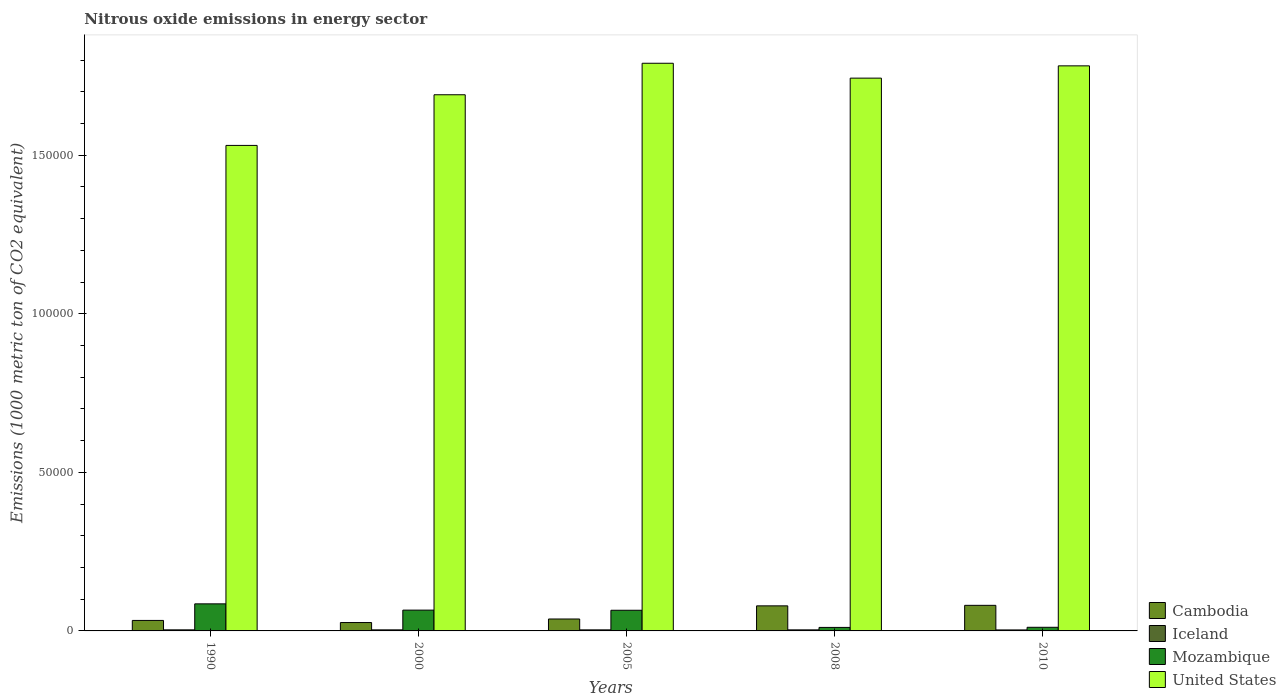In how many cases, is the number of bars for a given year not equal to the number of legend labels?
Offer a very short reply. 0. What is the amount of nitrous oxide emitted in Iceland in 2000?
Your answer should be compact. 331.8. Across all years, what is the maximum amount of nitrous oxide emitted in Mozambique?
Your answer should be compact. 8537. Across all years, what is the minimum amount of nitrous oxide emitted in United States?
Offer a very short reply. 1.53e+05. In which year was the amount of nitrous oxide emitted in Mozambique minimum?
Keep it short and to the point. 2008. What is the total amount of nitrous oxide emitted in Mozambique in the graph?
Provide a short and direct response. 2.39e+04. What is the difference between the amount of nitrous oxide emitted in Mozambique in 1990 and that in 2005?
Offer a terse response. 2022.8. What is the difference between the amount of nitrous oxide emitted in Iceland in 2000 and the amount of nitrous oxide emitted in United States in 1990?
Make the answer very short. -1.53e+05. What is the average amount of nitrous oxide emitted in Cambodia per year?
Keep it short and to the point. 5136.94. In the year 2000, what is the difference between the amount of nitrous oxide emitted in Cambodia and amount of nitrous oxide emitted in Mozambique?
Provide a succinct answer. -3912.3. What is the ratio of the amount of nitrous oxide emitted in Mozambique in 1990 to that in 2000?
Ensure brevity in your answer.  1.3. Is the amount of nitrous oxide emitted in United States in 2000 less than that in 2005?
Your response must be concise. Yes. Is the difference between the amount of nitrous oxide emitted in Cambodia in 1990 and 2008 greater than the difference between the amount of nitrous oxide emitted in Mozambique in 1990 and 2008?
Your answer should be compact. No. What is the difference between the highest and the second highest amount of nitrous oxide emitted in Mozambique?
Provide a short and direct response. 1979.8. What is the difference between the highest and the lowest amount of nitrous oxide emitted in Cambodia?
Offer a terse response. 5421.9. In how many years, is the amount of nitrous oxide emitted in United States greater than the average amount of nitrous oxide emitted in United States taken over all years?
Ensure brevity in your answer.  3. Is it the case that in every year, the sum of the amount of nitrous oxide emitted in Iceland and amount of nitrous oxide emitted in Mozambique is greater than the sum of amount of nitrous oxide emitted in United States and amount of nitrous oxide emitted in Cambodia?
Keep it short and to the point. No. What does the 3rd bar from the left in 1990 represents?
Ensure brevity in your answer.  Mozambique. Is it the case that in every year, the sum of the amount of nitrous oxide emitted in Cambodia and amount of nitrous oxide emitted in United States is greater than the amount of nitrous oxide emitted in Iceland?
Provide a succinct answer. Yes. Are all the bars in the graph horizontal?
Give a very brief answer. No. What is the difference between two consecutive major ticks on the Y-axis?
Provide a succinct answer. 5.00e+04. Does the graph contain any zero values?
Provide a short and direct response. No. Does the graph contain grids?
Offer a very short reply. No. What is the title of the graph?
Keep it short and to the point. Nitrous oxide emissions in energy sector. What is the label or title of the X-axis?
Your answer should be very brief. Years. What is the label or title of the Y-axis?
Provide a short and direct response. Emissions (1000 metric ton of CO2 equivalent). What is the Emissions (1000 metric ton of CO2 equivalent) in Cambodia in 1990?
Your answer should be very brief. 3309.2. What is the Emissions (1000 metric ton of CO2 equivalent) in Iceland in 1990?
Give a very brief answer. 336.3. What is the Emissions (1000 metric ton of CO2 equivalent) of Mozambique in 1990?
Your response must be concise. 8537. What is the Emissions (1000 metric ton of CO2 equivalent) in United States in 1990?
Your answer should be compact. 1.53e+05. What is the Emissions (1000 metric ton of CO2 equivalent) of Cambodia in 2000?
Keep it short and to the point. 2644.9. What is the Emissions (1000 metric ton of CO2 equivalent) of Iceland in 2000?
Provide a short and direct response. 331.8. What is the Emissions (1000 metric ton of CO2 equivalent) of Mozambique in 2000?
Offer a very short reply. 6557.2. What is the Emissions (1000 metric ton of CO2 equivalent) of United States in 2000?
Keep it short and to the point. 1.69e+05. What is the Emissions (1000 metric ton of CO2 equivalent) of Cambodia in 2005?
Provide a short and direct response. 3761.1. What is the Emissions (1000 metric ton of CO2 equivalent) in Iceland in 2005?
Offer a very short reply. 332.8. What is the Emissions (1000 metric ton of CO2 equivalent) in Mozambique in 2005?
Keep it short and to the point. 6514.2. What is the Emissions (1000 metric ton of CO2 equivalent) of United States in 2005?
Make the answer very short. 1.79e+05. What is the Emissions (1000 metric ton of CO2 equivalent) in Cambodia in 2008?
Provide a short and direct response. 7902.7. What is the Emissions (1000 metric ton of CO2 equivalent) in Iceland in 2008?
Give a very brief answer. 330.8. What is the Emissions (1000 metric ton of CO2 equivalent) in Mozambique in 2008?
Keep it short and to the point. 1104.1. What is the Emissions (1000 metric ton of CO2 equivalent) of United States in 2008?
Your answer should be very brief. 1.74e+05. What is the Emissions (1000 metric ton of CO2 equivalent) in Cambodia in 2010?
Your answer should be very brief. 8066.8. What is the Emissions (1000 metric ton of CO2 equivalent) in Iceland in 2010?
Provide a short and direct response. 311.8. What is the Emissions (1000 metric ton of CO2 equivalent) of Mozambique in 2010?
Ensure brevity in your answer.  1147.2. What is the Emissions (1000 metric ton of CO2 equivalent) in United States in 2010?
Your response must be concise. 1.78e+05. Across all years, what is the maximum Emissions (1000 metric ton of CO2 equivalent) in Cambodia?
Your response must be concise. 8066.8. Across all years, what is the maximum Emissions (1000 metric ton of CO2 equivalent) of Iceland?
Make the answer very short. 336.3. Across all years, what is the maximum Emissions (1000 metric ton of CO2 equivalent) in Mozambique?
Make the answer very short. 8537. Across all years, what is the maximum Emissions (1000 metric ton of CO2 equivalent) in United States?
Make the answer very short. 1.79e+05. Across all years, what is the minimum Emissions (1000 metric ton of CO2 equivalent) in Cambodia?
Give a very brief answer. 2644.9. Across all years, what is the minimum Emissions (1000 metric ton of CO2 equivalent) of Iceland?
Your response must be concise. 311.8. Across all years, what is the minimum Emissions (1000 metric ton of CO2 equivalent) of Mozambique?
Your response must be concise. 1104.1. Across all years, what is the minimum Emissions (1000 metric ton of CO2 equivalent) of United States?
Keep it short and to the point. 1.53e+05. What is the total Emissions (1000 metric ton of CO2 equivalent) of Cambodia in the graph?
Ensure brevity in your answer.  2.57e+04. What is the total Emissions (1000 metric ton of CO2 equivalent) in Iceland in the graph?
Your answer should be very brief. 1643.5. What is the total Emissions (1000 metric ton of CO2 equivalent) in Mozambique in the graph?
Make the answer very short. 2.39e+04. What is the total Emissions (1000 metric ton of CO2 equivalent) in United States in the graph?
Give a very brief answer. 8.54e+05. What is the difference between the Emissions (1000 metric ton of CO2 equivalent) of Cambodia in 1990 and that in 2000?
Your answer should be very brief. 664.3. What is the difference between the Emissions (1000 metric ton of CO2 equivalent) of Mozambique in 1990 and that in 2000?
Your answer should be very brief. 1979.8. What is the difference between the Emissions (1000 metric ton of CO2 equivalent) of United States in 1990 and that in 2000?
Offer a very short reply. -1.60e+04. What is the difference between the Emissions (1000 metric ton of CO2 equivalent) of Cambodia in 1990 and that in 2005?
Ensure brevity in your answer.  -451.9. What is the difference between the Emissions (1000 metric ton of CO2 equivalent) of Iceland in 1990 and that in 2005?
Give a very brief answer. 3.5. What is the difference between the Emissions (1000 metric ton of CO2 equivalent) in Mozambique in 1990 and that in 2005?
Your answer should be very brief. 2022.8. What is the difference between the Emissions (1000 metric ton of CO2 equivalent) of United States in 1990 and that in 2005?
Keep it short and to the point. -2.59e+04. What is the difference between the Emissions (1000 metric ton of CO2 equivalent) of Cambodia in 1990 and that in 2008?
Ensure brevity in your answer.  -4593.5. What is the difference between the Emissions (1000 metric ton of CO2 equivalent) in Mozambique in 1990 and that in 2008?
Make the answer very short. 7432.9. What is the difference between the Emissions (1000 metric ton of CO2 equivalent) in United States in 1990 and that in 2008?
Keep it short and to the point. -2.12e+04. What is the difference between the Emissions (1000 metric ton of CO2 equivalent) in Cambodia in 1990 and that in 2010?
Offer a very short reply. -4757.6. What is the difference between the Emissions (1000 metric ton of CO2 equivalent) of Mozambique in 1990 and that in 2010?
Your answer should be compact. 7389.8. What is the difference between the Emissions (1000 metric ton of CO2 equivalent) of United States in 1990 and that in 2010?
Provide a short and direct response. -2.51e+04. What is the difference between the Emissions (1000 metric ton of CO2 equivalent) of Cambodia in 2000 and that in 2005?
Your response must be concise. -1116.2. What is the difference between the Emissions (1000 metric ton of CO2 equivalent) of Mozambique in 2000 and that in 2005?
Your answer should be very brief. 43. What is the difference between the Emissions (1000 metric ton of CO2 equivalent) in United States in 2000 and that in 2005?
Make the answer very short. -9931.2. What is the difference between the Emissions (1000 metric ton of CO2 equivalent) of Cambodia in 2000 and that in 2008?
Provide a succinct answer. -5257.8. What is the difference between the Emissions (1000 metric ton of CO2 equivalent) in Mozambique in 2000 and that in 2008?
Your answer should be very brief. 5453.1. What is the difference between the Emissions (1000 metric ton of CO2 equivalent) of United States in 2000 and that in 2008?
Keep it short and to the point. -5242.4. What is the difference between the Emissions (1000 metric ton of CO2 equivalent) in Cambodia in 2000 and that in 2010?
Offer a terse response. -5421.9. What is the difference between the Emissions (1000 metric ton of CO2 equivalent) in Mozambique in 2000 and that in 2010?
Your response must be concise. 5410. What is the difference between the Emissions (1000 metric ton of CO2 equivalent) in United States in 2000 and that in 2010?
Offer a very short reply. -9113.5. What is the difference between the Emissions (1000 metric ton of CO2 equivalent) in Cambodia in 2005 and that in 2008?
Give a very brief answer. -4141.6. What is the difference between the Emissions (1000 metric ton of CO2 equivalent) of Mozambique in 2005 and that in 2008?
Your answer should be very brief. 5410.1. What is the difference between the Emissions (1000 metric ton of CO2 equivalent) in United States in 2005 and that in 2008?
Offer a terse response. 4688.8. What is the difference between the Emissions (1000 metric ton of CO2 equivalent) in Cambodia in 2005 and that in 2010?
Your answer should be compact. -4305.7. What is the difference between the Emissions (1000 metric ton of CO2 equivalent) of Iceland in 2005 and that in 2010?
Give a very brief answer. 21. What is the difference between the Emissions (1000 metric ton of CO2 equivalent) in Mozambique in 2005 and that in 2010?
Ensure brevity in your answer.  5367. What is the difference between the Emissions (1000 metric ton of CO2 equivalent) in United States in 2005 and that in 2010?
Ensure brevity in your answer.  817.7. What is the difference between the Emissions (1000 metric ton of CO2 equivalent) of Cambodia in 2008 and that in 2010?
Give a very brief answer. -164.1. What is the difference between the Emissions (1000 metric ton of CO2 equivalent) of Mozambique in 2008 and that in 2010?
Offer a terse response. -43.1. What is the difference between the Emissions (1000 metric ton of CO2 equivalent) of United States in 2008 and that in 2010?
Your response must be concise. -3871.1. What is the difference between the Emissions (1000 metric ton of CO2 equivalent) of Cambodia in 1990 and the Emissions (1000 metric ton of CO2 equivalent) of Iceland in 2000?
Your answer should be very brief. 2977.4. What is the difference between the Emissions (1000 metric ton of CO2 equivalent) of Cambodia in 1990 and the Emissions (1000 metric ton of CO2 equivalent) of Mozambique in 2000?
Provide a short and direct response. -3248. What is the difference between the Emissions (1000 metric ton of CO2 equivalent) of Cambodia in 1990 and the Emissions (1000 metric ton of CO2 equivalent) of United States in 2000?
Offer a very short reply. -1.66e+05. What is the difference between the Emissions (1000 metric ton of CO2 equivalent) of Iceland in 1990 and the Emissions (1000 metric ton of CO2 equivalent) of Mozambique in 2000?
Keep it short and to the point. -6220.9. What is the difference between the Emissions (1000 metric ton of CO2 equivalent) of Iceland in 1990 and the Emissions (1000 metric ton of CO2 equivalent) of United States in 2000?
Offer a terse response. -1.69e+05. What is the difference between the Emissions (1000 metric ton of CO2 equivalent) in Mozambique in 1990 and the Emissions (1000 metric ton of CO2 equivalent) in United States in 2000?
Provide a short and direct response. -1.61e+05. What is the difference between the Emissions (1000 metric ton of CO2 equivalent) of Cambodia in 1990 and the Emissions (1000 metric ton of CO2 equivalent) of Iceland in 2005?
Ensure brevity in your answer.  2976.4. What is the difference between the Emissions (1000 metric ton of CO2 equivalent) of Cambodia in 1990 and the Emissions (1000 metric ton of CO2 equivalent) of Mozambique in 2005?
Offer a very short reply. -3205. What is the difference between the Emissions (1000 metric ton of CO2 equivalent) in Cambodia in 1990 and the Emissions (1000 metric ton of CO2 equivalent) in United States in 2005?
Ensure brevity in your answer.  -1.76e+05. What is the difference between the Emissions (1000 metric ton of CO2 equivalent) of Iceland in 1990 and the Emissions (1000 metric ton of CO2 equivalent) of Mozambique in 2005?
Provide a short and direct response. -6177.9. What is the difference between the Emissions (1000 metric ton of CO2 equivalent) in Iceland in 1990 and the Emissions (1000 metric ton of CO2 equivalent) in United States in 2005?
Keep it short and to the point. -1.79e+05. What is the difference between the Emissions (1000 metric ton of CO2 equivalent) of Mozambique in 1990 and the Emissions (1000 metric ton of CO2 equivalent) of United States in 2005?
Offer a terse response. -1.70e+05. What is the difference between the Emissions (1000 metric ton of CO2 equivalent) in Cambodia in 1990 and the Emissions (1000 metric ton of CO2 equivalent) in Iceland in 2008?
Offer a terse response. 2978.4. What is the difference between the Emissions (1000 metric ton of CO2 equivalent) in Cambodia in 1990 and the Emissions (1000 metric ton of CO2 equivalent) in Mozambique in 2008?
Provide a succinct answer. 2205.1. What is the difference between the Emissions (1000 metric ton of CO2 equivalent) in Cambodia in 1990 and the Emissions (1000 metric ton of CO2 equivalent) in United States in 2008?
Your answer should be very brief. -1.71e+05. What is the difference between the Emissions (1000 metric ton of CO2 equivalent) of Iceland in 1990 and the Emissions (1000 metric ton of CO2 equivalent) of Mozambique in 2008?
Offer a very short reply. -767.8. What is the difference between the Emissions (1000 metric ton of CO2 equivalent) in Iceland in 1990 and the Emissions (1000 metric ton of CO2 equivalent) in United States in 2008?
Your response must be concise. -1.74e+05. What is the difference between the Emissions (1000 metric ton of CO2 equivalent) in Mozambique in 1990 and the Emissions (1000 metric ton of CO2 equivalent) in United States in 2008?
Give a very brief answer. -1.66e+05. What is the difference between the Emissions (1000 metric ton of CO2 equivalent) of Cambodia in 1990 and the Emissions (1000 metric ton of CO2 equivalent) of Iceland in 2010?
Your answer should be very brief. 2997.4. What is the difference between the Emissions (1000 metric ton of CO2 equivalent) in Cambodia in 1990 and the Emissions (1000 metric ton of CO2 equivalent) in Mozambique in 2010?
Offer a very short reply. 2162. What is the difference between the Emissions (1000 metric ton of CO2 equivalent) of Cambodia in 1990 and the Emissions (1000 metric ton of CO2 equivalent) of United States in 2010?
Your response must be concise. -1.75e+05. What is the difference between the Emissions (1000 metric ton of CO2 equivalent) in Iceland in 1990 and the Emissions (1000 metric ton of CO2 equivalent) in Mozambique in 2010?
Offer a terse response. -810.9. What is the difference between the Emissions (1000 metric ton of CO2 equivalent) of Iceland in 1990 and the Emissions (1000 metric ton of CO2 equivalent) of United States in 2010?
Your answer should be compact. -1.78e+05. What is the difference between the Emissions (1000 metric ton of CO2 equivalent) of Mozambique in 1990 and the Emissions (1000 metric ton of CO2 equivalent) of United States in 2010?
Provide a succinct answer. -1.70e+05. What is the difference between the Emissions (1000 metric ton of CO2 equivalent) of Cambodia in 2000 and the Emissions (1000 metric ton of CO2 equivalent) of Iceland in 2005?
Provide a short and direct response. 2312.1. What is the difference between the Emissions (1000 metric ton of CO2 equivalent) in Cambodia in 2000 and the Emissions (1000 metric ton of CO2 equivalent) in Mozambique in 2005?
Make the answer very short. -3869.3. What is the difference between the Emissions (1000 metric ton of CO2 equivalent) of Cambodia in 2000 and the Emissions (1000 metric ton of CO2 equivalent) of United States in 2005?
Ensure brevity in your answer.  -1.76e+05. What is the difference between the Emissions (1000 metric ton of CO2 equivalent) in Iceland in 2000 and the Emissions (1000 metric ton of CO2 equivalent) in Mozambique in 2005?
Make the answer very short. -6182.4. What is the difference between the Emissions (1000 metric ton of CO2 equivalent) in Iceland in 2000 and the Emissions (1000 metric ton of CO2 equivalent) in United States in 2005?
Your answer should be compact. -1.79e+05. What is the difference between the Emissions (1000 metric ton of CO2 equivalent) of Mozambique in 2000 and the Emissions (1000 metric ton of CO2 equivalent) of United States in 2005?
Provide a succinct answer. -1.72e+05. What is the difference between the Emissions (1000 metric ton of CO2 equivalent) of Cambodia in 2000 and the Emissions (1000 metric ton of CO2 equivalent) of Iceland in 2008?
Give a very brief answer. 2314.1. What is the difference between the Emissions (1000 metric ton of CO2 equivalent) in Cambodia in 2000 and the Emissions (1000 metric ton of CO2 equivalent) in Mozambique in 2008?
Your response must be concise. 1540.8. What is the difference between the Emissions (1000 metric ton of CO2 equivalent) of Cambodia in 2000 and the Emissions (1000 metric ton of CO2 equivalent) of United States in 2008?
Your answer should be compact. -1.72e+05. What is the difference between the Emissions (1000 metric ton of CO2 equivalent) in Iceland in 2000 and the Emissions (1000 metric ton of CO2 equivalent) in Mozambique in 2008?
Provide a succinct answer. -772.3. What is the difference between the Emissions (1000 metric ton of CO2 equivalent) of Iceland in 2000 and the Emissions (1000 metric ton of CO2 equivalent) of United States in 2008?
Make the answer very short. -1.74e+05. What is the difference between the Emissions (1000 metric ton of CO2 equivalent) in Mozambique in 2000 and the Emissions (1000 metric ton of CO2 equivalent) in United States in 2008?
Keep it short and to the point. -1.68e+05. What is the difference between the Emissions (1000 metric ton of CO2 equivalent) in Cambodia in 2000 and the Emissions (1000 metric ton of CO2 equivalent) in Iceland in 2010?
Offer a terse response. 2333.1. What is the difference between the Emissions (1000 metric ton of CO2 equivalent) in Cambodia in 2000 and the Emissions (1000 metric ton of CO2 equivalent) in Mozambique in 2010?
Your answer should be compact. 1497.7. What is the difference between the Emissions (1000 metric ton of CO2 equivalent) in Cambodia in 2000 and the Emissions (1000 metric ton of CO2 equivalent) in United States in 2010?
Your response must be concise. -1.76e+05. What is the difference between the Emissions (1000 metric ton of CO2 equivalent) of Iceland in 2000 and the Emissions (1000 metric ton of CO2 equivalent) of Mozambique in 2010?
Make the answer very short. -815.4. What is the difference between the Emissions (1000 metric ton of CO2 equivalent) in Iceland in 2000 and the Emissions (1000 metric ton of CO2 equivalent) in United States in 2010?
Keep it short and to the point. -1.78e+05. What is the difference between the Emissions (1000 metric ton of CO2 equivalent) of Mozambique in 2000 and the Emissions (1000 metric ton of CO2 equivalent) of United States in 2010?
Offer a terse response. -1.72e+05. What is the difference between the Emissions (1000 metric ton of CO2 equivalent) in Cambodia in 2005 and the Emissions (1000 metric ton of CO2 equivalent) in Iceland in 2008?
Give a very brief answer. 3430.3. What is the difference between the Emissions (1000 metric ton of CO2 equivalent) in Cambodia in 2005 and the Emissions (1000 metric ton of CO2 equivalent) in Mozambique in 2008?
Make the answer very short. 2657. What is the difference between the Emissions (1000 metric ton of CO2 equivalent) in Cambodia in 2005 and the Emissions (1000 metric ton of CO2 equivalent) in United States in 2008?
Provide a succinct answer. -1.71e+05. What is the difference between the Emissions (1000 metric ton of CO2 equivalent) in Iceland in 2005 and the Emissions (1000 metric ton of CO2 equivalent) in Mozambique in 2008?
Provide a short and direct response. -771.3. What is the difference between the Emissions (1000 metric ton of CO2 equivalent) in Iceland in 2005 and the Emissions (1000 metric ton of CO2 equivalent) in United States in 2008?
Provide a succinct answer. -1.74e+05. What is the difference between the Emissions (1000 metric ton of CO2 equivalent) of Mozambique in 2005 and the Emissions (1000 metric ton of CO2 equivalent) of United States in 2008?
Provide a short and direct response. -1.68e+05. What is the difference between the Emissions (1000 metric ton of CO2 equivalent) in Cambodia in 2005 and the Emissions (1000 metric ton of CO2 equivalent) in Iceland in 2010?
Ensure brevity in your answer.  3449.3. What is the difference between the Emissions (1000 metric ton of CO2 equivalent) of Cambodia in 2005 and the Emissions (1000 metric ton of CO2 equivalent) of Mozambique in 2010?
Your answer should be compact. 2613.9. What is the difference between the Emissions (1000 metric ton of CO2 equivalent) of Cambodia in 2005 and the Emissions (1000 metric ton of CO2 equivalent) of United States in 2010?
Your answer should be compact. -1.74e+05. What is the difference between the Emissions (1000 metric ton of CO2 equivalent) in Iceland in 2005 and the Emissions (1000 metric ton of CO2 equivalent) in Mozambique in 2010?
Give a very brief answer. -814.4. What is the difference between the Emissions (1000 metric ton of CO2 equivalent) in Iceland in 2005 and the Emissions (1000 metric ton of CO2 equivalent) in United States in 2010?
Ensure brevity in your answer.  -1.78e+05. What is the difference between the Emissions (1000 metric ton of CO2 equivalent) of Mozambique in 2005 and the Emissions (1000 metric ton of CO2 equivalent) of United States in 2010?
Offer a very short reply. -1.72e+05. What is the difference between the Emissions (1000 metric ton of CO2 equivalent) of Cambodia in 2008 and the Emissions (1000 metric ton of CO2 equivalent) of Iceland in 2010?
Make the answer very short. 7590.9. What is the difference between the Emissions (1000 metric ton of CO2 equivalent) in Cambodia in 2008 and the Emissions (1000 metric ton of CO2 equivalent) in Mozambique in 2010?
Your answer should be very brief. 6755.5. What is the difference between the Emissions (1000 metric ton of CO2 equivalent) in Cambodia in 2008 and the Emissions (1000 metric ton of CO2 equivalent) in United States in 2010?
Give a very brief answer. -1.70e+05. What is the difference between the Emissions (1000 metric ton of CO2 equivalent) in Iceland in 2008 and the Emissions (1000 metric ton of CO2 equivalent) in Mozambique in 2010?
Keep it short and to the point. -816.4. What is the difference between the Emissions (1000 metric ton of CO2 equivalent) in Iceland in 2008 and the Emissions (1000 metric ton of CO2 equivalent) in United States in 2010?
Provide a succinct answer. -1.78e+05. What is the difference between the Emissions (1000 metric ton of CO2 equivalent) in Mozambique in 2008 and the Emissions (1000 metric ton of CO2 equivalent) in United States in 2010?
Make the answer very short. -1.77e+05. What is the average Emissions (1000 metric ton of CO2 equivalent) in Cambodia per year?
Your answer should be very brief. 5136.94. What is the average Emissions (1000 metric ton of CO2 equivalent) of Iceland per year?
Your answer should be very brief. 328.7. What is the average Emissions (1000 metric ton of CO2 equivalent) in Mozambique per year?
Your response must be concise. 4771.94. What is the average Emissions (1000 metric ton of CO2 equivalent) in United States per year?
Your answer should be very brief. 1.71e+05. In the year 1990, what is the difference between the Emissions (1000 metric ton of CO2 equivalent) of Cambodia and Emissions (1000 metric ton of CO2 equivalent) of Iceland?
Give a very brief answer. 2972.9. In the year 1990, what is the difference between the Emissions (1000 metric ton of CO2 equivalent) in Cambodia and Emissions (1000 metric ton of CO2 equivalent) in Mozambique?
Your response must be concise. -5227.8. In the year 1990, what is the difference between the Emissions (1000 metric ton of CO2 equivalent) in Cambodia and Emissions (1000 metric ton of CO2 equivalent) in United States?
Offer a very short reply. -1.50e+05. In the year 1990, what is the difference between the Emissions (1000 metric ton of CO2 equivalent) in Iceland and Emissions (1000 metric ton of CO2 equivalent) in Mozambique?
Keep it short and to the point. -8200.7. In the year 1990, what is the difference between the Emissions (1000 metric ton of CO2 equivalent) of Iceland and Emissions (1000 metric ton of CO2 equivalent) of United States?
Your response must be concise. -1.53e+05. In the year 1990, what is the difference between the Emissions (1000 metric ton of CO2 equivalent) in Mozambique and Emissions (1000 metric ton of CO2 equivalent) in United States?
Offer a terse response. -1.45e+05. In the year 2000, what is the difference between the Emissions (1000 metric ton of CO2 equivalent) of Cambodia and Emissions (1000 metric ton of CO2 equivalent) of Iceland?
Offer a terse response. 2313.1. In the year 2000, what is the difference between the Emissions (1000 metric ton of CO2 equivalent) of Cambodia and Emissions (1000 metric ton of CO2 equivalent) of Mozambique?
Your answer should be very brief. -3912.3. In the year 2000, what is the difference between the Emissions (1000 metric ton of CO2 equivalent) of Cambodia and Emissions (1000 metric ton of CO2 equivalent) of United States?
Your answer should be compact. -1.66e+05. In the year 2000, what is the difference between the Emissions (1000 metric ton of CO2 equivalent) of Iceland and Emissions (1000 metric ton of CO2 equivalent) of Mozambique?
Make the answer very short. -6225.4. In the year 2000, what is the difference between the Emissions (1000 metric ton of CO2 equivalent) of Iceland and Emissions (1000 metric ton of CO2 equivalent) of United States?
Your answer should be compact. -1.69e+05. In the year 2000, what is the difference between the Emissions (1000 metric ton of CO2 equivalent) of Mozambique and Emissions (1000 metric ton of CO2 equivalent) of United States?
Provide a succinct answer. -1.62e+05. In the year 2005, what is the difference between the Emissions (1000 metric ton of CO2 equivalent) of Cambodia and Emissions (1000 metric ton of CO2 equivalent) of Iceland?
Keep it short and to the point. 3428.3. In the year 2005, what is the difference between the Emissions (1000 metric ton of CO2 equivalent) in Cambodia and Emissions (1000 metric ton of CO2 equivalent) in Mozambique?
Keep it short and to the point. -2753.1. In the year 2005, what is the difference between the Emissions (1000 metric ton of CO2 equivalent) of Cambodia and Emissions (1000 metric ton of CO2 equivalent) of United States?
Ensure brevity in your answer.  -1.75e+05. In the year 2005, what is the difference between the Emissions (1000 metric ton of CO2 equivalent) in Iceland and Emissions (1000 metric ton of CO2 equivalent) in Mozambique?
Your response must be concise. -6181.4. In the year 2005, what is the difference between the Emissions (1000 metric ton of CO2 equivalent) in Iceland and Emissions (1000 metric ton of CO2 equivalent) in United States?
Provide a succinct answer. -1.79e+05. In the year 2005, what is the difference between the Emissions (1000 metric ton of CO2 equivalent) of Mozambique and Emissions (1000 metric ton of CO2 equivalent) of United States?
Provide a succinct answer. -1.72e+05. In the year 2008, what is the difference between the Emissions (1000 metric ton of CO2 equivalent) of Cambodia and Emissions (1000 metric ton of CO2 equivalent) of Iceland?
Keep it short and to the point. 7571.9. In the year 2008, what is the difference between the Emissions (1000 metric ton of CO2 equivalent) in Cambodia and Emissions (1000 metric ton of CO2 equivalent) in Mozambique?
Make the answer very short. 6798.6. In the year 2008, what is the difference between the Emissions (1000 metric ton of CO2 equivalent) of Cambodia and Emissions (1000 metric ton of CO2 equivalent) of United States?
Provide a short and direct response. -1.66e+05. In the year 2008, what is the difference between the Emissions (1000 metric ton of CO2 equivalent) of Iceland and Emissions (1000 metric ton of CO2 equivalent) of Mozambique?
Keep it short and to the point. -773.3. In the year 2008, what is the difference between the Emissions (1000 metric ton of CO2 equivalent) in Iceland and Emissions (1000 metric ton of CO2 equivalent) in United States?
Offer a very short reply. -1.74e+05. In the year 2008, what is the difference between the Emissions (1000 metric ton of CO2 equivalent) of Mozambique and Emissions (1000 metric ton of CO2 equivalent) of United States?
Offer a terse response. -1.73e+05. In the year 2010, what is the difference between the Emissions (1000 metric ton of CO2 equivalent) of Cambodia and Emissions (1000 metric ton of CO2 equivalent) of Iceland?
Your answer should be compact. 7755. In the year 2010, what is the difference between the Emissions (1000 metric ton of CO2 equivalent) in Cambodia and Emissions (1000 metric ton of CO2 equivalent) in Mozambique?
Offer a very short reply. 6919.6. In the year 2010, what is the difference between the Emissions (1000 metric ton of CO2 equivalent) in Cambodia and Emissions (1000 metric ton of CO2 equivalent) in United States?
Give a very brief answer. -1.70e+05. In the year 2010, what is the difference between the Emissions (1000 metric ton of CO2 equivalent) of Iceland and Emissions (1000 metric ton of CO2 equivalent) of Mozambique?
Give a very brief answer. -835.4. In the year 2010, what is the difference between the Emissions (1000 metric ton of CO2 equivalent) of Iceland and Emissions (1000 metric ton of CO2 equivalent) of United States?
Offer a terse response. -1.78e+05. In the year 2010, what is the difference between the Emissions (1000 metric ton of CO2 equivalent) of Mozambique and Emissions (1000 metric ton of CO2 equivalent) of United States?
Offer a terse response. -1.77e+05. What is the ratio of the Emissions (1000 metric ton of CO2 equivalent) in Cambodia in 1990 to that in 2000?
Your response must be concise. 1.25. What is the ratio of the Emissions (1000 metric ton of CO2 equivalent) in Iceland in 1990 to that in 2000?
Your response must be concise. 1.01. What is the ratio of the Emissions (1000 metric ton of CO2 equivalent) in Mozambique in 1990 to that in 2000?
Give a very brief answer. 1.3. What is the ratio of the Emissions (1000 metric ton of CO2 equivalent) in United States in 1990 to that in 2000?
Keep it short and to the point. 0.91. What is the ratio of the Emissions (1000 metric ton of CO2 equivalent) of Cambodia in 1990 to that in 2005?
Make the answer very short. 0.88. What is the ratio of the Emissions (1000 metric ton of CO2 equivalent) in Iceland in 1990 to that in 2005?
Offer a very short reply. 1.01. What is the ratio of the Emissions (1000 metric ton of CO2 equivalent) in Mozambique in 1990 to that in 2005?
Your answer should be compact. 1.31. What is the ratio of the Emissions (1000 metric ton of CO2 equivalent) in United States in 1990 to that in 2005?
Your response must be concise. 0.86. What is the ratio of the Emissions (1000 metric ton of CO2 equivalent) in Cambodia in 1990 to that in 2008?
Ensure brevity in your answer.  0.42. What is the ratio of the Emissions (1000 metric ton of CO2 equivalent) in Iceland in 1990 to that in 2008?
Your answer should be very brief. 1.02. What is the ratio of the Emissions (1000 metric ton of CO2 equivalent) of Mozambique in 1990 to that in 2008?
Make the answer very short. 7.73. What is the ratio of the Emissions (1000 metric ton of CO2 equivalent) in United States in 1990 to that in 2008?
Your answer should be very brief. 0.88. What is the ratio of the Emissions (1000 metric ton of CO2 equivalent) in Cambodia in 1990 to that in 2010?
Ensure brevity in your answer.  0.41. What is the ratio of the Emissions (1000 metric ton of CO2 equivalent) in Iceland in 1990 to that in 2010?
Keep it short and to the point. 1.08. What is the ratio of the Emissions (1000 metric ton of CO2 equivalent) of Mozambique in 1990 to that in 2010?
Ensure brevity in your answer.  7.44. What is the ratio of the Emissions (1000 metric ton of CO2 equivalent) of United States in 1990 to that in 2010?
Provide a short and direct response. 0.86. What is the ratio of the Emissions (1000 metric ton of CO2 equivalent) in Cambodia in 2000 to that in 2005?
Make the answer very short. 0.7. What is the ratio of the Emissions (1000 metric ton of CO2 equivalent) of Mozambique in 2000 to that in 2005?
Ensure brevity in your answer.  1.01. What is the ratio of the Emissions (1000 metric ton of CO2 equivalent) of United States in 2000 to that in 2005?
Make the answer very short. 0.94. What is the ratio of the Emissions (1000 metric ton of CO2 equivalent) of Cambodia in 2000 to that in 2008?
Keep it short and to the point. 0.33. What is the ratio of the Emissions (1000 metric ton of CO2 equivalent) in Iceland in 2000 to that in 2008?
Provide a succinct answer. 1. What is the ratio of the Emissions (1000 metric ton of CO2 equivalent) in Mozambique in 2000 to that in 2008?
Provide a short and direct response. 5.94. What is the ratio of the Emissions (1000 metric ton of CO2 equivalent) in United States in 2000 to that in 2008?
Offer a very short reply. 0.97. What is the ratio of the Emissions (1000 metric ton of CO2 equivalent) of Cambodia in 2000 to that in 2010?
Your answer should be compact. 0.33. What is the ratio of the Emissions (1000 metric ton of CO2 equivalent) of Iceland in 2000 to that in 2010?
Offer a terse response. 1.06. What is the ratio of the Emissions (1000 metric ton of CO2 equivalent) of Mozambique in 2000 to that in 2010?
Keep it short and to the point. 5.72. What is the ratio of the Emissions (1000 metric ton of CO2 equivalent) of United States in 2000 to that in 2010?
Offer a terse response. 0.95. What is the ratio of the Emissions (1000 metric ton of CO2 equivalent) in Cambodia in 2005 to that in 2008?
Offer a terse response. 0.48. What is the ratio of the Emissions (1000 metric ton of CO2 equivalent) of Mozambique in 2005 to that in 2008?
Make the answer very short. 5.9. What is the ratio of the Emissions (1000 metric ton of CO2 equivalent) in United States in 2005 to that in 2008?
Your answer should be very brief. 1.03. What is the ratio of the Emissions (1000 metric ton of CO2 equivalent) of Cambodia in 2005 to that in 2010?
Provide a succinct answer. 0.47. What is the ratio of the Emissions (1000 metric ton of CO2 equivalent) of Iceland in 2005 to that in 2010?
Give a very brief answer. 1.07. What is the ratio of the Emissions (1000 metric ton of CO2 equivalent) in Mozambique in 2005 to that in 2010?
Keep it short and to the point. 5.68. What is the ratio of the Emissions (1000 metric ton of CO2 equivalent) of Cambodia in 2008 to that in 2010?
Ensure brevity in your answer.  0.98. What is the ratio of the Emissions (1000 metric ton of CO2 equivalent) in Iceland in 2008 to that in 2010?
Provide a succinct answer. 1.06. What is the ratio of the Emissions (1000 metric ton of CO2 equivalent) in Mozambique in 2008 to that in 2010?
Offer a very short reply. 0.96. What is the ratio of the Emissions (1000 metric ton of CO2 equivalent) of United States in 2008 to that in 2010?
Ensure brevity in your answer.  0.98. What is the difference between the highest and the second highest Emissions (1000 metric ton of CO2 equivalent) in Cambodia?
Make the answer very short. 164.1. What is the difference between the highest and the second highest Emissions (1000 metric ton of CO2 equivalent) in Mozambique?
Your answer should be compact. 1979.8. What is the difference between the highest and the second highest Emissions (1000 metric ton of CO2 equivalent) in United States?
Make the answer very short. 817.7. What is the difference between the highest and the lowest Emissions (1000 metric ton of CO2 equivalent) of Cambodia?
Provide a succinct answer. 5421.9. What is the difference between the highest and the lowest Emissions (1000 metric ton of CO2 equivalent) of Iceland?
Provide a succinct answer. 24.5. What is the difference between the highest and the lowest Emissions (1000 metric ton of CO2 equivalent) in Mozambique?
Ensure brevity in your answer.  7432.9. What is the difference between the highest and the lowest Emissions (1000 metric ton of CO2 equivalent) in United States?
Give a very brief answer. 2.59e+04. 